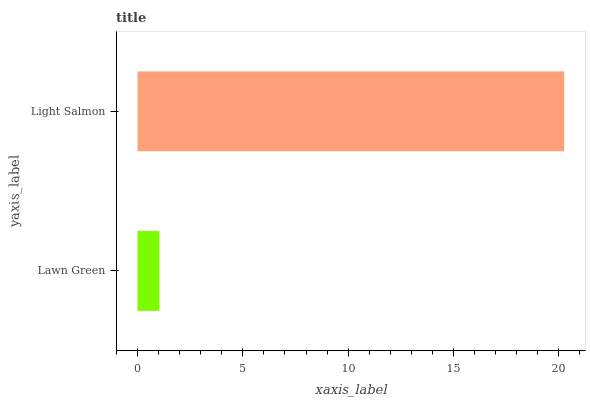Is Lawn Green the minimum?
Answer yes or no. Yes. Is Light Salmon the maximum?
Answer yes or no. Yes. Is Light Salmon the minimum?
Answer yes or no. No. Is Light Salmon greater than Lawn Green?
Answer yes or no. Yes. Is Lawn Green less than Light Salmon?
Answer yes or no. Yes. Is Lawn Green greater than Light Salmon?
Answer yes or no. No. Is Light Salmon less than Lawn Green?
Answer yes or no. No. Is Light Salmon the high median?
Answer yes or no. Yes. Is Lawn Green the low median?
Answer yes or no. Yes. Is Lawn Green the high median?
Answer yes or no. No. Is Light Salmon the low median?
Answer yes or no. No. 